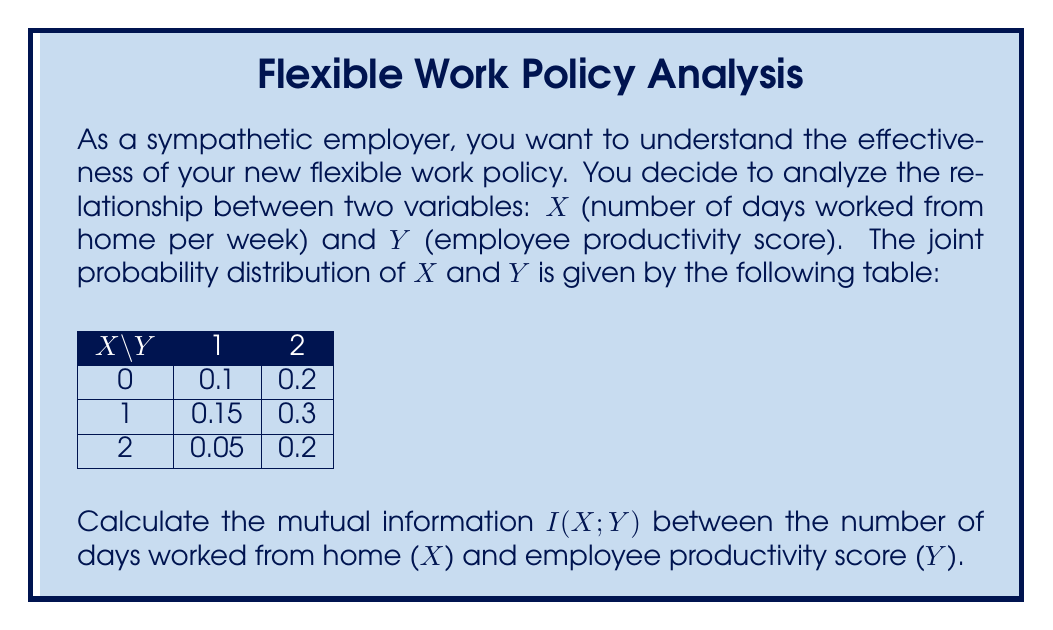Give your solution to this math problem. To calculate the mutual information $I(X;Y)$, we'll follow these steps:

1) First, we need to calculate the marginal probabilities for X and Y:

   $P(X=0) = 0.1 + 0.2 = 0.3$
   $P(X=1) = 0.15 + 0.3 = 0.45$
   $P(X=2) = 0.05 + 0.2 = 0.25$

   $P(Y=1) = 0.1 + 0.15 + 0.05 = 0.3$
   $P(Y=2) = 0.2 + 0.3 + 0.2 = 0.7$

2) The mutual information is defined as:

   $$I(X;Y) = \sum_{x,y} P(x,y) \log_2 \frac{P(x,y)}{P(x)P(y)}$$

3) Let's calculate each term:

   For $X=0, Y=1$: $0.1 \log_2 \frac{0.1}{0.3 \cdot 0.3} = 0.1 \log_2 1.11 = 0.0152$
   For $X=0, Y=2$: $0.2 \log_2 \frac{0.2}{0.3 \cdot 0.7} = 0.2 \log_2 0.95 = -0.0145$
   For $X=1, Y=1$: $0.15 \log_2 \frac{0.15}{0.45 \cdot 0.3} = 0.15 \log_2 1.11 = 0.0228$
   For $X=1, Y=2$: $0.3 \log_2 \frac{0.3}{0.45 \cdot 0.7} = 0.3 \log_2 0.95 = -0.0217$
   For $X=2, Y=1$: $0.05 \log_2 \frac{0.05}{0.25 \cdot 0.3} = 0.05 \log_2 0.67 = -0.0248$
   For $X=2, Y=2$: $0.2 \log_2 \frac{0.2}{0.25 \cdot 0.7} = 0.2 \log_2 1.14 = 0.0377$

4) Sum all these terms:

   $I(X;Y) = 0.0152 - 0.0145 + 0.0228 - 0.0217 - 0.0248 + 0.0377 = 0.0147$ bits
Answer: $0.0147$ bits 